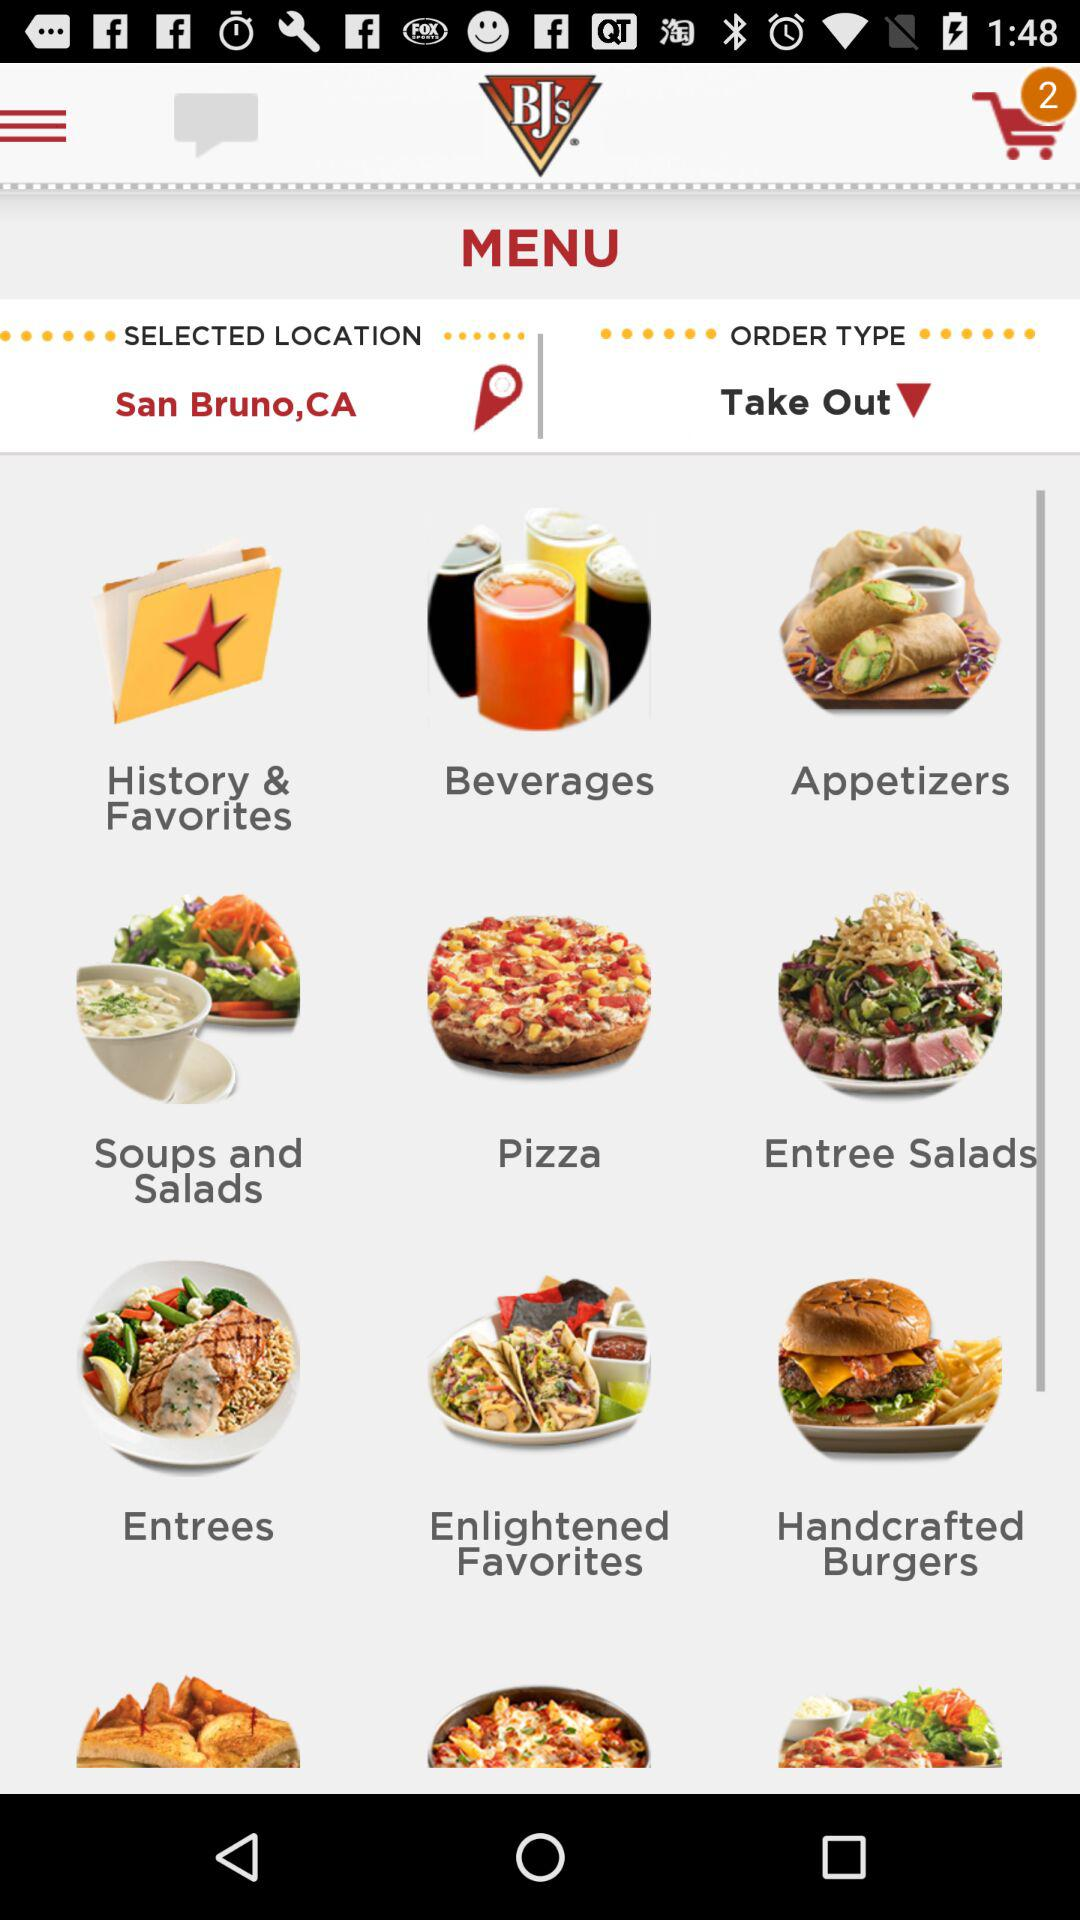How many items are in the shopping cart? There are 2 items in the shopping cart. 